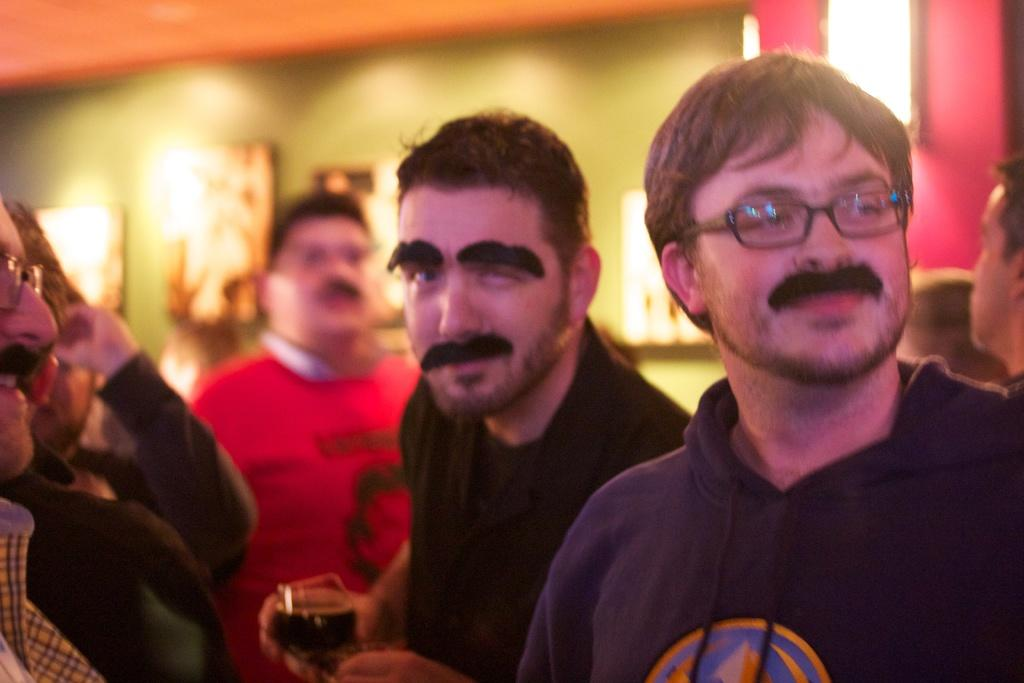What are the people in the image doing? There are men standing in the image. Can you describe what one of the men is holding? A man is holding a glass. What can be seen in the background of the image? There is a man in a red t-shirt in the background and objects on the wall. Can you tell me how many snails are crawling on the wall in the image? There are no snails present in the image; the objects on the wall do not include any snails. What type of lock is visible on the wall in the image? There is no lock visible on the wall in the image; only objects are mentioned. 